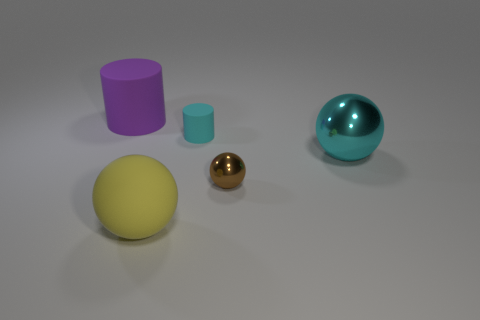Can you describe how the shadows in the image give clues about the light source? Certainly! The shadows in the image are consistently cast on the right side of the objects and at a slight angle, indicating that the light source is situated to the upper left of the scene. The soft edges of the shadows suggest that the light source is not overly harsh and may be diffused, akin to an overcast day or a softbox light in photography. The varying lengths and angles of the shadows also give hints to the three-dimensional placement of the objects in relation to the light source and the camera view. 